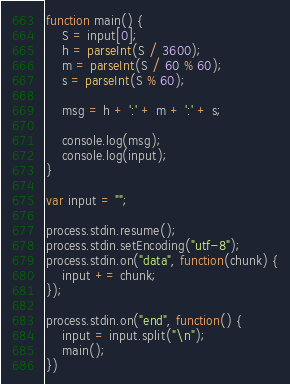<code> <loc_0><loc_0><loc_500><loc_500><_JavaScript_>function main() {
	S = input[0];
	h = parseInt(S / 3600);
	m = parseInt(S / 60 % 60);
	s = parseInt(S % 60);

	msg = h + ':' + m + ':' + s;

	console.log(msg);
	console.log(input);
}

var input = "";

process.stdin.resume();
process.stdin.setEncoding("utf-8");
process.stdin.on("data", function(chunk) {
	input += chunk;
});

process.stdin.on("end", function() {
	input = input.split("\n");
	main();
})</code> 